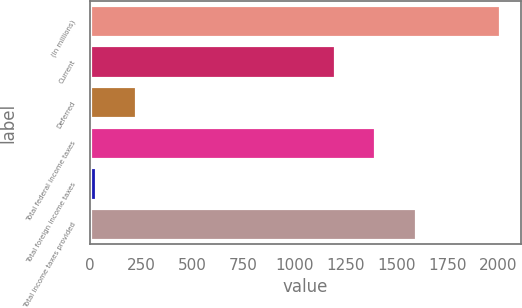Convert chart. <chart><loc_0><loc_0><loc_500><loc_500><bar_chart><fcel>(In millions)<fcel>Current<fcel>Deferred<fcel>Total federal income taxes<fcel>Total foreign income taxes<fcel>Total income taxes provided<nl><fcel>2007<fcel>1199<fcel>226.8<fcel>1396.8<fcel>29<fcel>1594.6<nl></chart> 